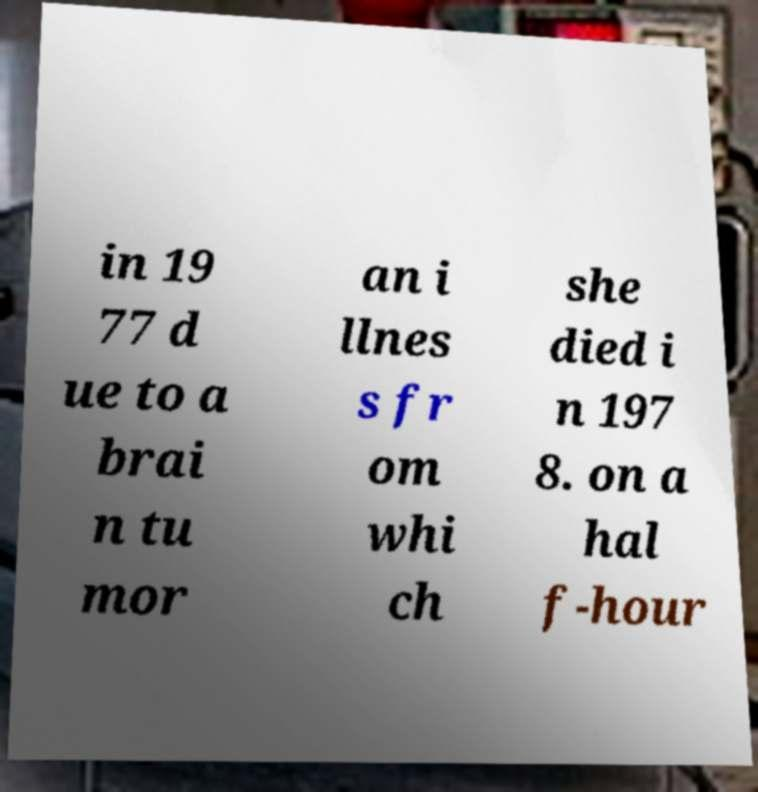Can you read and provide the text displayed in the image?This photo seems to have some interesting text. Can you extract and type it out for me? in 19 77 d ue to a brai n tu mor an i llnes s fr om whi ch she died i n 197 8. on a hal f-hour 